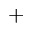<formula> <loc_0><loc_0><loc_500><loc_500>^ { + }</formula> 